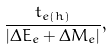Convert formula to latex. <formula><loc_0><loc_0><loc_500><loc_500>\frac { t _ { e ( h ) } } { | \Delta E _ { e } + \Delta M _ { e } | } ,</formula> 